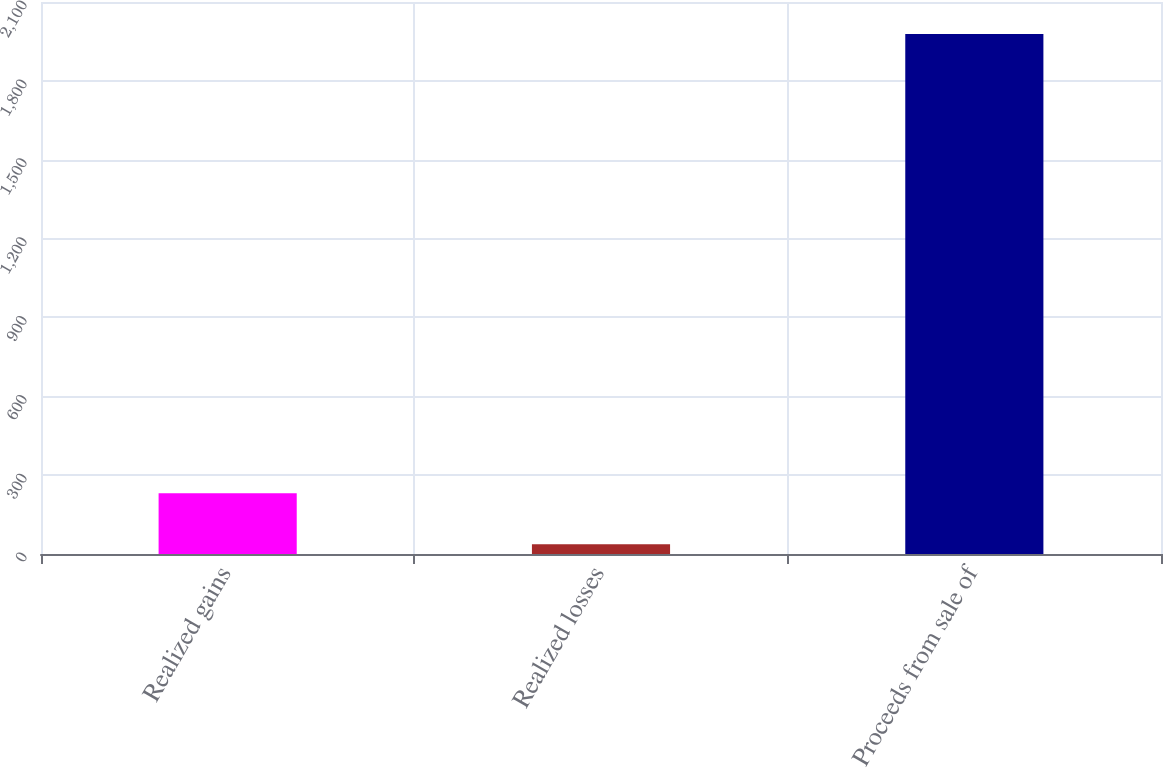<chart> <loc_0><loc_0><loc_500><loc_500><bar_chart><fcel>Realized gains<fcel>Realized losses<fcel>Proceeds from sale of<nl><fcel>231.1<fcel>37<fcel>1978<nl></chart> 